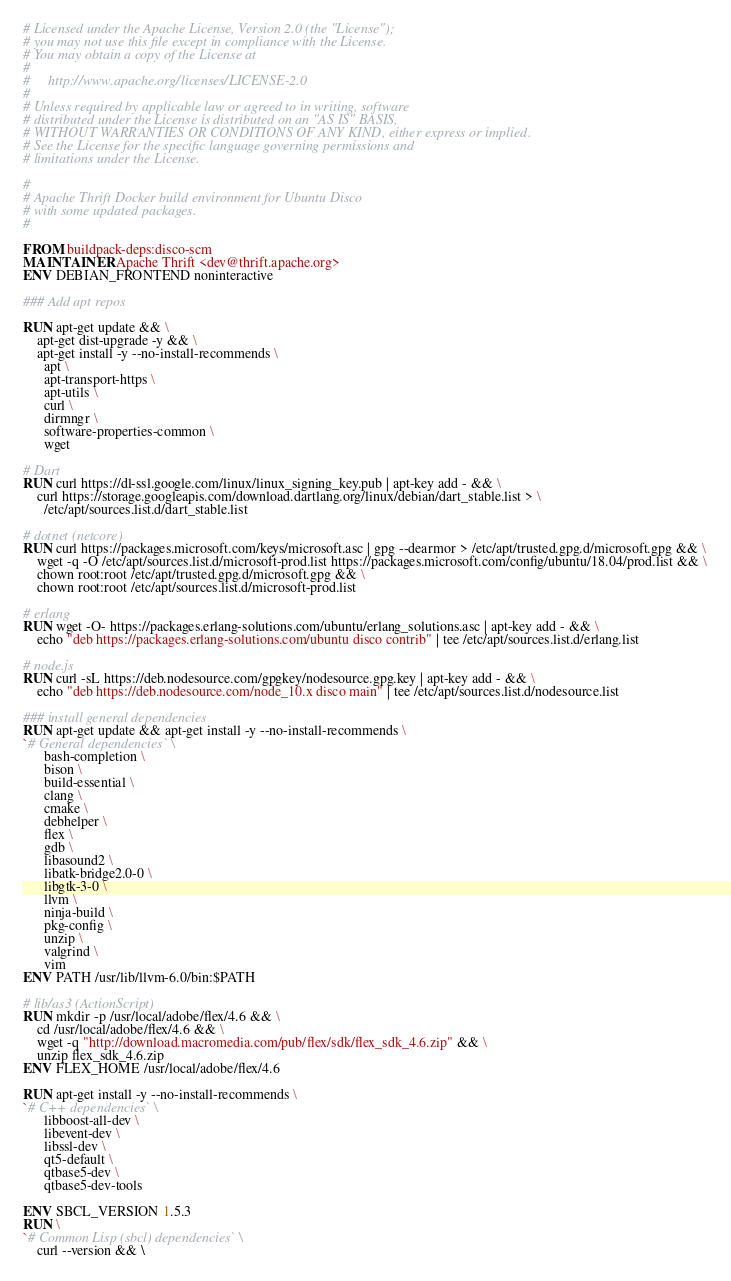<code> <loc_0><loc_0><loc_500><loc_500><_Dockerfile_># Licensed under the Apache License, Version 2.0 (the "License");
# you may not use this file except in compliance with the License.
# You may obtain a copy of the License at
#
#     http://www.apache.org/licenses/LICENSE-2.0
#
# Unless required by applicable law or agreed to in writing, software
# distributed under the License is distributed on an "AS IS" BASIS,
# WITHOUT WARRANTIES OR CONDITIONS OF ANY KIND, either express or implied.
# See the License for the specific language governing permissions and
# limitations under the License.

#
# Apache Thrift Docker build environment for Ubuntu Disco
# with some updated packages.
#

FROM buildpack-deps:disco-scm
MAINTAINER Apache Thrift <dev@thrift.apache.org>
ENV DEBIAN_FRONTEND noninteractive

### Add apt repos

RUN apt-get update && \
    apt-get dist-upgrade -y && \
    apt-get install -y --no-install-recommends \
      apt \
      apt-transport-https \
      apt-utils \
      curl \
      dirmngr \
      software-properties-common \
      wget

# Dart
RUN curl https://dl-ssl.google.com/linux/linux_signing_key.pub | apt-key add - && \
    curl https://storage.googleapis.com/download.dartlang.org/linux/debian/dart_stable.list > \
      /etc/apt/sources.list.d/dart_stable.list

# dotnet (netcore)
RUN curl https://packages.microsoft.com/keys/microsoft.asc | gpg --dearmor > /etc/apt/trusted.gpg.d/microsoft.gpg && \
    wget -q -O /etc/apt/sources.list.d/microsoft-prod.list https://packages.microsoft.com/config/ubuntu/18.04/prod.list && \
    chown root:root /etc/apt/trusted.gpg.d/microsoft.gpg && \
    chown root:root /etc/apt/sources.list.d/microsoft-prod.list

# erlang
RUN wget -O- https://packages.erlang-solutions.com/ubuntu/erlang_solutions.asc | apt-key add - && \
    echo "deb https://packages.erlang-solutions.com/ubuntu disco contrib" | tee /etc/apt/sources.list.d/erlang.list

# node.js
RUN curl -sL https://deb.nodesource.com/gpgkey/nodesource.gpg.key | apt-key add - && \
    echo "deb https://deb.nodesource.com/node_10.x disco main" | tee /etc/apt/sources.list.d/nodesource.list

### install general dependencies
RUN apt-get update && apt-get install -y --no-install-recommends \
`# General dependencies` \
      bash-completion \
      bison \
      build-essential \
      clang \
      cmake \
      debhelper \
      flex \
      gdb \
      libasound2 \
      libatk-bridge2.0-0 \
      libgtk-3-0 \
      llvm \
      ninja-build \
      pkg-config \
      unzip \
      valgrind \
      vim
ENV PATH /usr/lib/llvm-6.0/bin:$PATH

# lib/as3 (ActionScript)
RUN mkdir -p /usr/local/adobe/flex/4.6 && \
    cd /usr/local/adobe/flex/4.6 && \
    wget -q "http://download.macromedia.com/pub/flex/sdk/flex_sdk_4.6.zip" && \
    unzip flex_sdk_4.6.zip
ENV FLEX_HOME /usr/local/adobe/flex/4.6

RUN apt-get install -y --no-install-recommends \
`# C++ dependencies` \
      libboost-all-dev \
      libevent-dev \
      libssl-dev \
      qt5-default \
      qtbase5-dev \
      qtbase5-dev-tools

ENV SBCL_VERSION 1.5.3
RUN \
`# Common Lisp (sbcl) dependencies` \
    curl --version && \</code> 